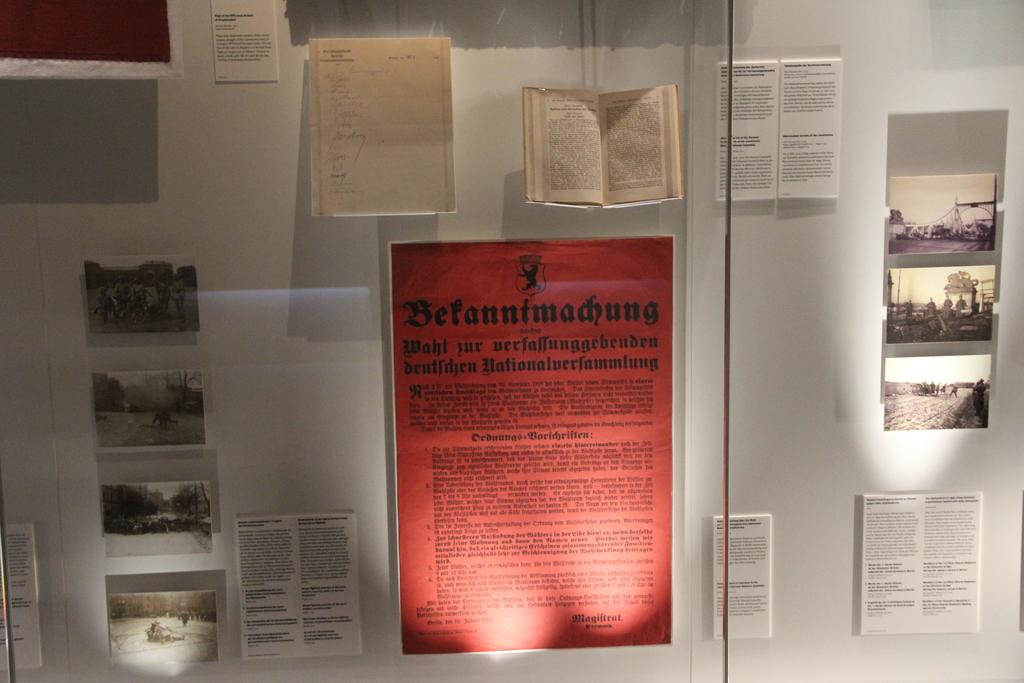What does it say at the top of the red paper?
Give a very brief answer. Befannimadhung. 